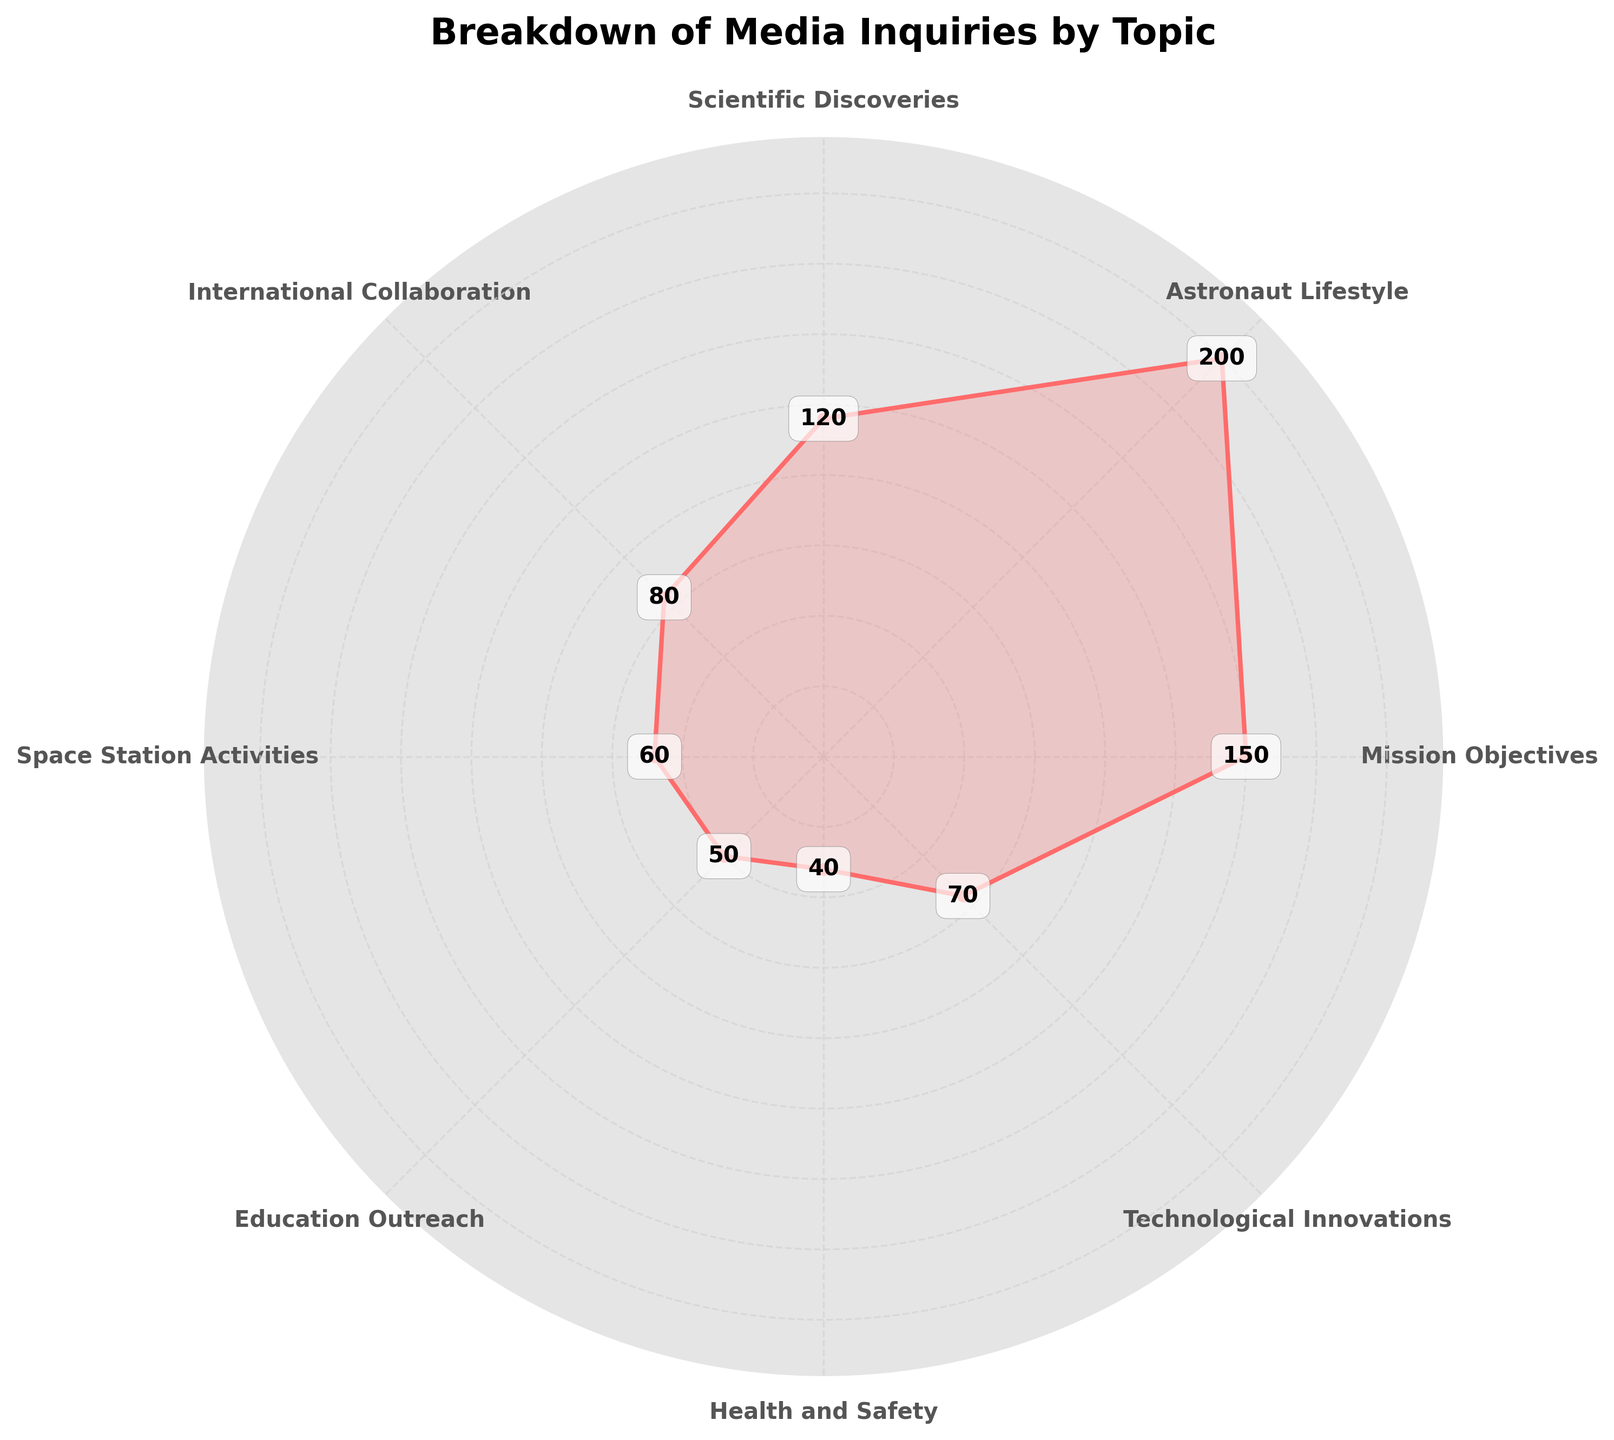what is the title of the figure? The title is displayed at the top of the chart. It reads "Breakdown of Media Inquiries by Topic" in bold font.
Answer: Breakdown of Media Inquiries by Topic Which topic received the highest number of inquiries? The topic with the highest radial line and value on the chart represents the highest number of inquiries, which is "Astronaut Lifestyle" with 200 inquiries.
Answer: Astronaut Lifestyle How many inquiries are there for Scientific Discoveries? The chart shows a radial line for "Scientific Discoveries" that is marked with the number of inquiries. The number is displayed as 120.
Answer: 120 Which topic received the least number of inquiries? The topic with the smallest radial line and the lowest value on the chart represents the least number of inquiries, which is "Health and Safety" with 40 inquiries.
Answer: Health and Safety What is the combined total of inquiries for Space Station Activities and Technological Innovations? Add the number of inquiries for "Space Station Activities" (60) and "Technological Innovations" (70). 60 + 70 = 130.
Answer: 130 How many more inquiries did Mission Objectives receive compared to International Collaboration? Subtract the number of inquiries for "International Collaboration" (80) from "Mission Objectives" (150). 150 - 80 = 70.
Answer: 70 Which two topics have the closest number of inquiries? Check the radial lines and values, "International Collaboration" has 80 inquiries, and "Technological Innovations" has 70 inquiries. The difference is only 10 inquiries, which is the smallest difference between two topics.
Answer: International Collaboration and Technological Innovations Is the number of inquiries about Education Outreach greater than the number of inquiries about Health and Safety? Compare the radial values for "Education Outreach" (50) and "Health and Safety" (40). 50 > 40, so yes.
Answer: Yes What is the average number of inquiries across all topics? Sum all inquiries (150 + 200 + 120 + 80 + 60 + 50 + 40 + 70) = 770. Divide the total by the number of topics (8). 770 / 8 = 96.25.
Answer: 96.25 Which topics received more inquiries than the average number of inquiries? The average number of inquiries is 96.25. The topics with inquiries greater than 96.25 are "Mission Objectives" (150), "Astronaut Lifestyle" (200), and "Scientific Discoveries" (120).
Answer: Mission Objectives, Astronaut Lifestyle, and Scientific Discoveries 